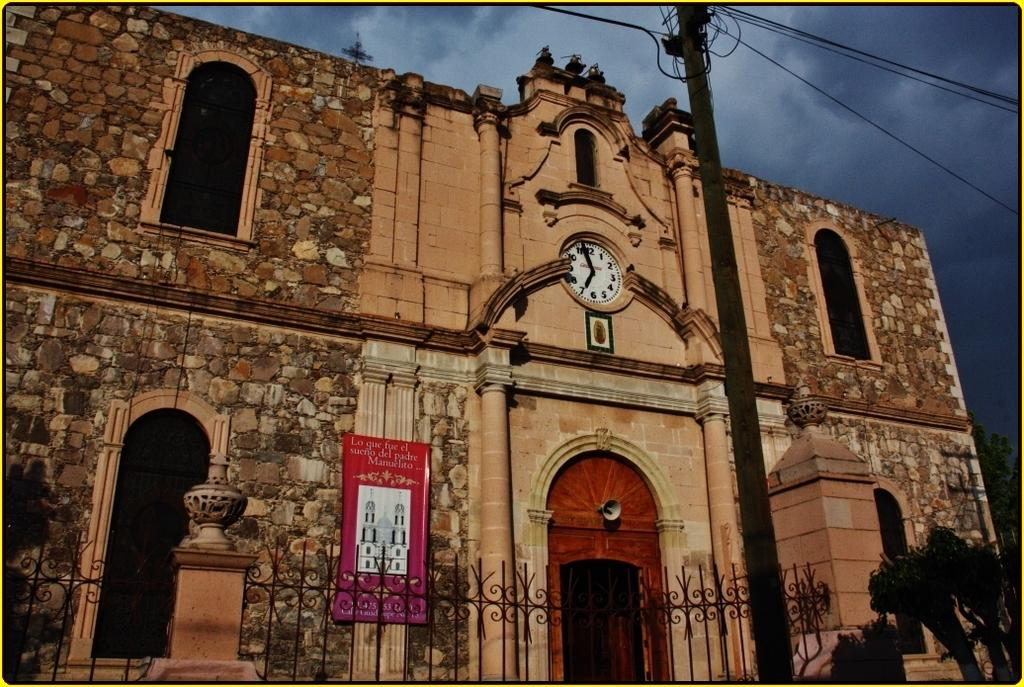<image>
Relay a brief, clear account of the picture shown. An old building with a sign that reads "Lo gue fue el sueno del padre manuelito...". 